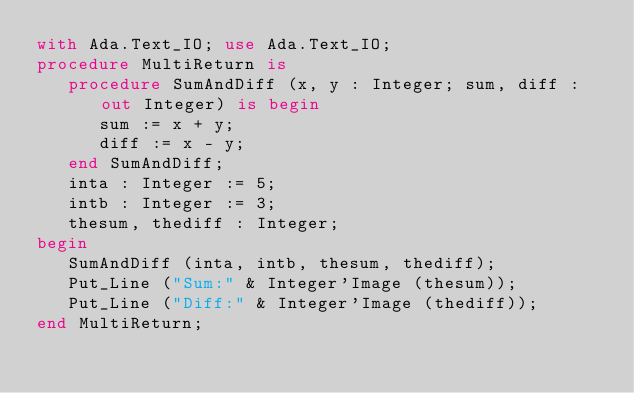<code> <loc_0><loc_0><loc_500><loc_500><_Ada_>with Ada.Text_IO; use Ada.Text_IO;
procedure MultiReturn is
   procedure SumAndDiff (x, y : Integer; sum, diff : out Integer) is begin
      sum := x + y;
      diff := x - y;
   end SumAndDiff;
   inta : Integer := 5;
   intb : Integer := 3;
   thesum, thediff : Integer;
begin
   SumAndDiff (inta, intb, thesum, thediff);
   Put_Line ("Sum:" & Integer'Image (thesum));
   Put_Line ("Diff:" & Integer'Image (thediff));
end MultiReturn;
</code> 